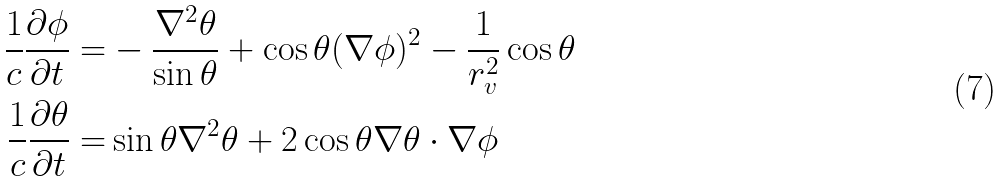<formula> <loc_0><loc_0><loc_500><loc_500>\frac { 1 } { c } \frac { \partial \phi } { \partial t } = & - \frac { \nabla ^ { 2 } \theta } { \sin \theta } + \cos \theta ( \nabla \phi ) ^ { 2 } - \frac { 1 } { r _ { v } ^ { 2 } } \cos \theta \\ \frac { 1 } { c } \frac { \partial \theta } { \partial t } = & \sin \theta \nabla ^ { 2 } \theta + 2 \cos \theta \nabla \theta \cdot \nabla \phi</formula> 